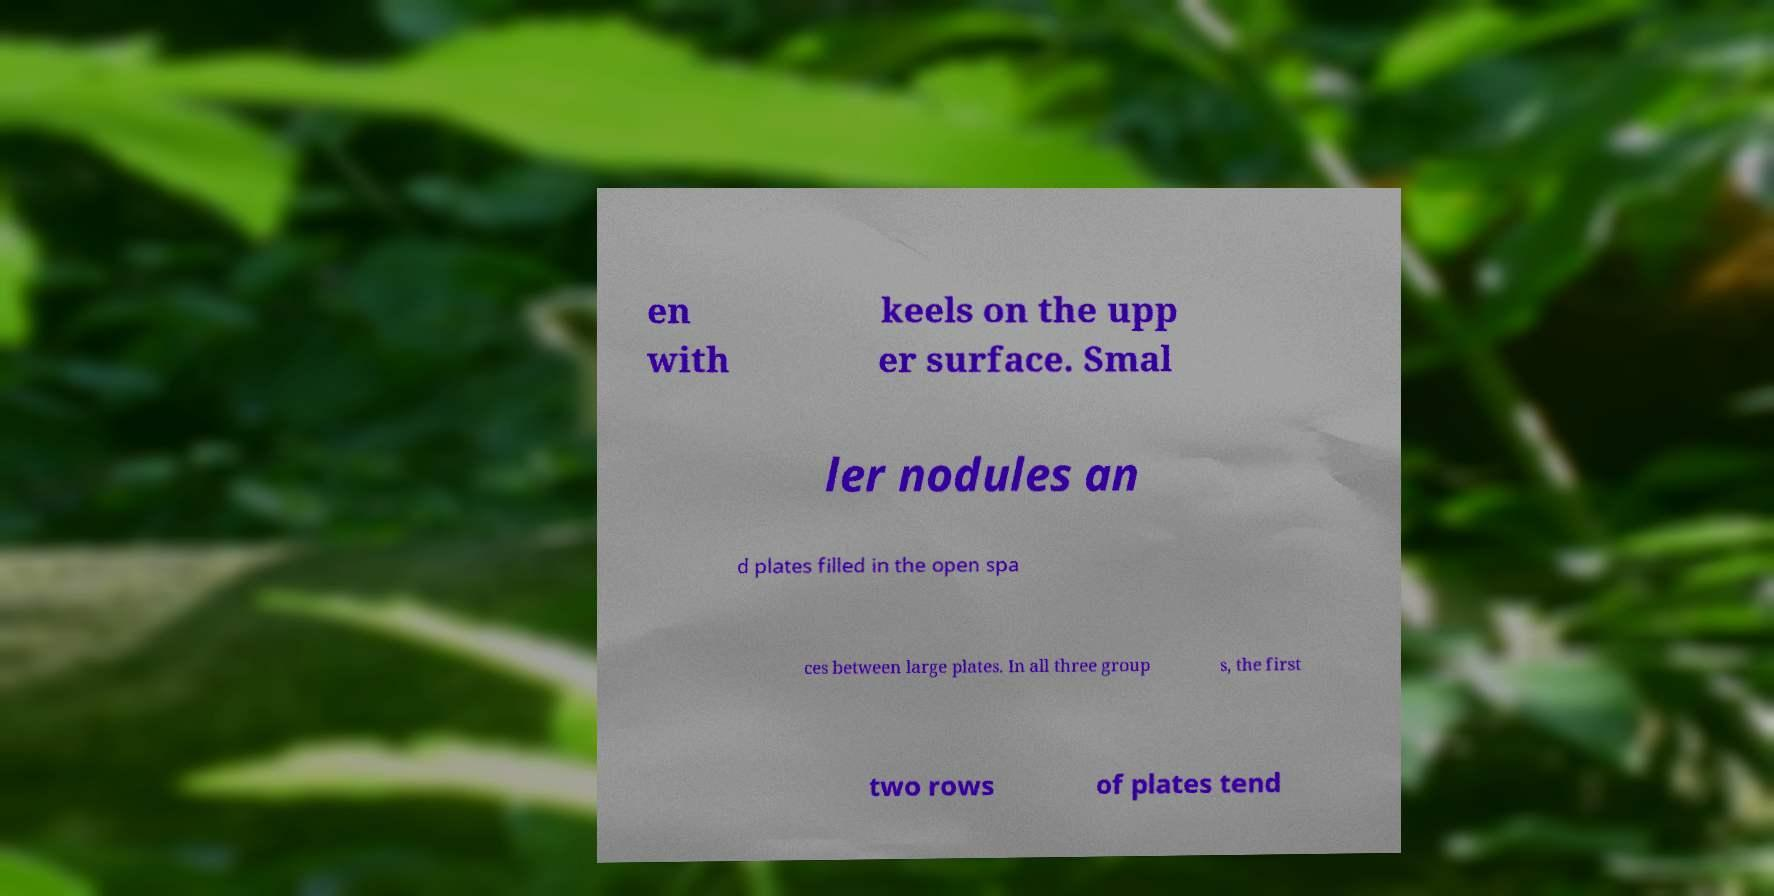Please identify and transcribe the text found in this image. en with keels on the upp er surface. Smal ler nodules an d plates filled in the open spa ces between large plates. In all three group s, the first two rows of plates tend 